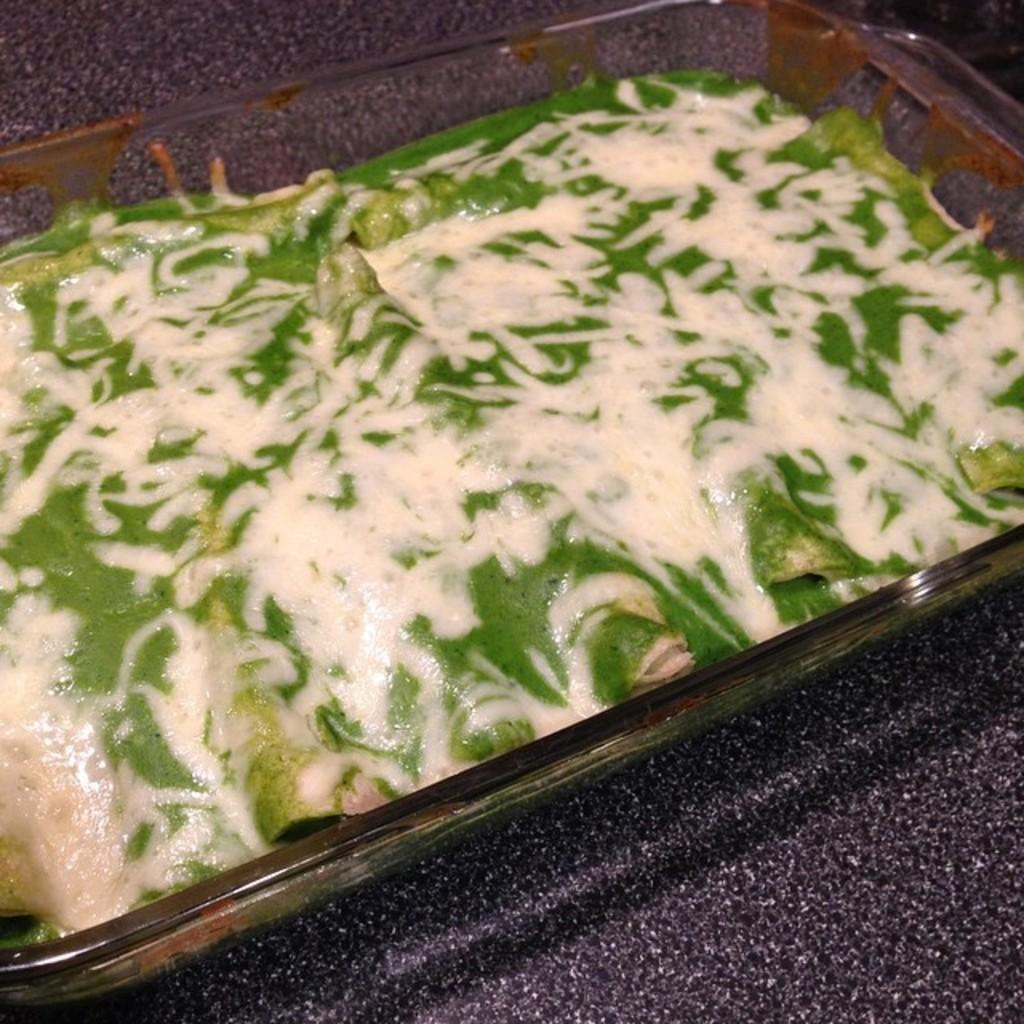What is in the bowl that is visible in the image? There is food in a bowl in the image. Can you describe the texture at the bottom of the image? The bottom of the image appears to have a marble-like texture. How many men are laboring in the summer heat in the image? There are no men or laborers present in the image; it only features a bowl of food and a marble-like texture at the bottom. 